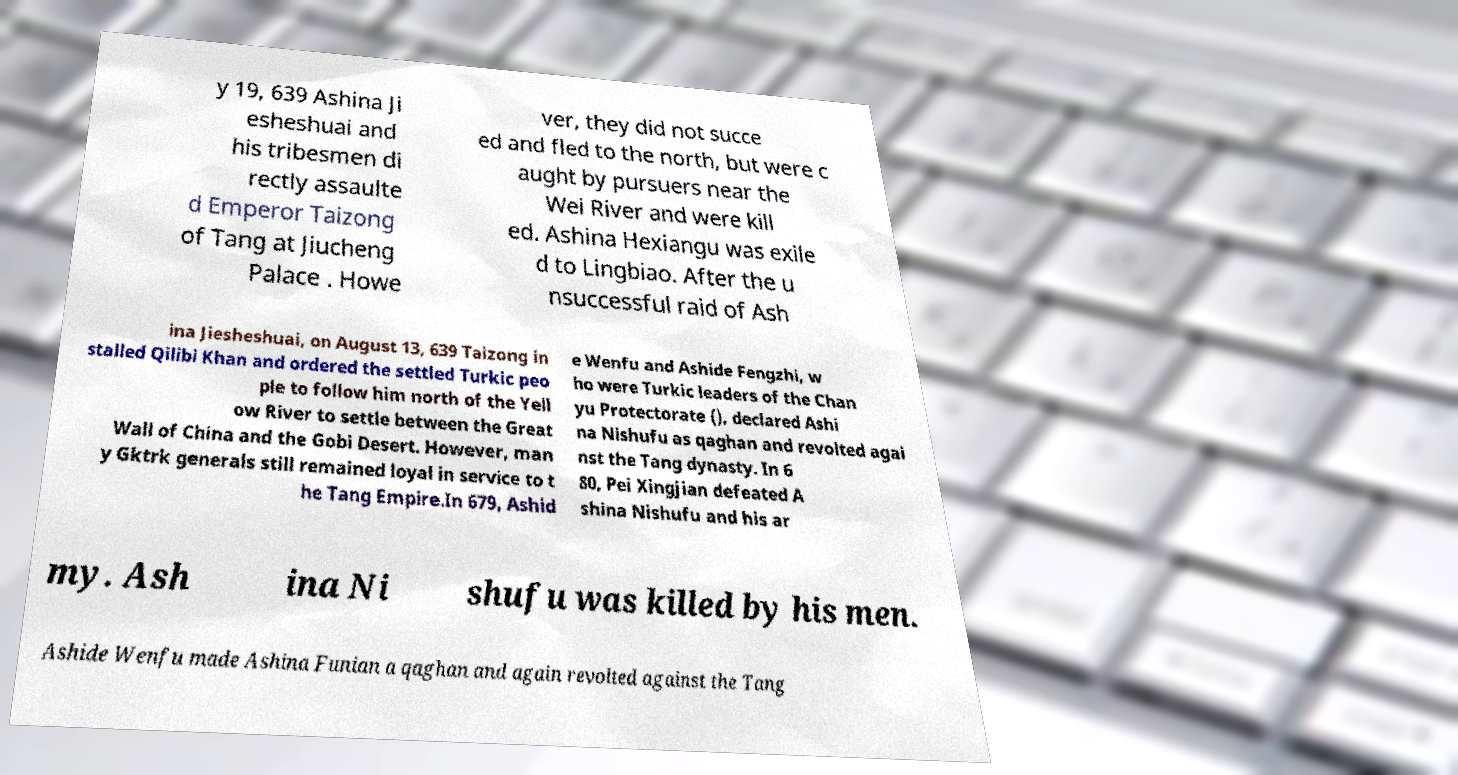There's text embedded in this image that I need extracted. Can you transcribe it verbatim? y 19, 639 Ashina Ji esheshuai and his tribesmen di rectly assaulte d Emperor Taizong of Tang at Jiucheng Palace . Howe ver, they did not succe ed and fled to the north, but were c aught by pursuers near the Wei River and were kill ed. Ashina Hexiangu was exile d to Lingbiao. After the u nsuccessful raid of Ash ina Jiesheshuai, on August 13, 639 Taizong in stalled Qilibi Khan and ordered the settled Turkic peo ple to follow him north of the Yell ow River to settle between the Great Wall of China and the Gobi Desert. However, man y Gktrk generals still remained loyal in service to t he Tang Empire.In 679, Ashid e Wenfu and Ashide Fengzhi, w ho were Turkic leaders of the Chan yu Protectorate (), declared Ashi na Nishufu as qaghan and revolted agai nst the Tang dynasty. In 6 80, Pei Xingjian defeated A shina Nishufu and his ar my. Ash ina Ni shufu was killed by his men. Ashide Wenfu made Ashina Funian a qaghan and again revolted against the Tang 